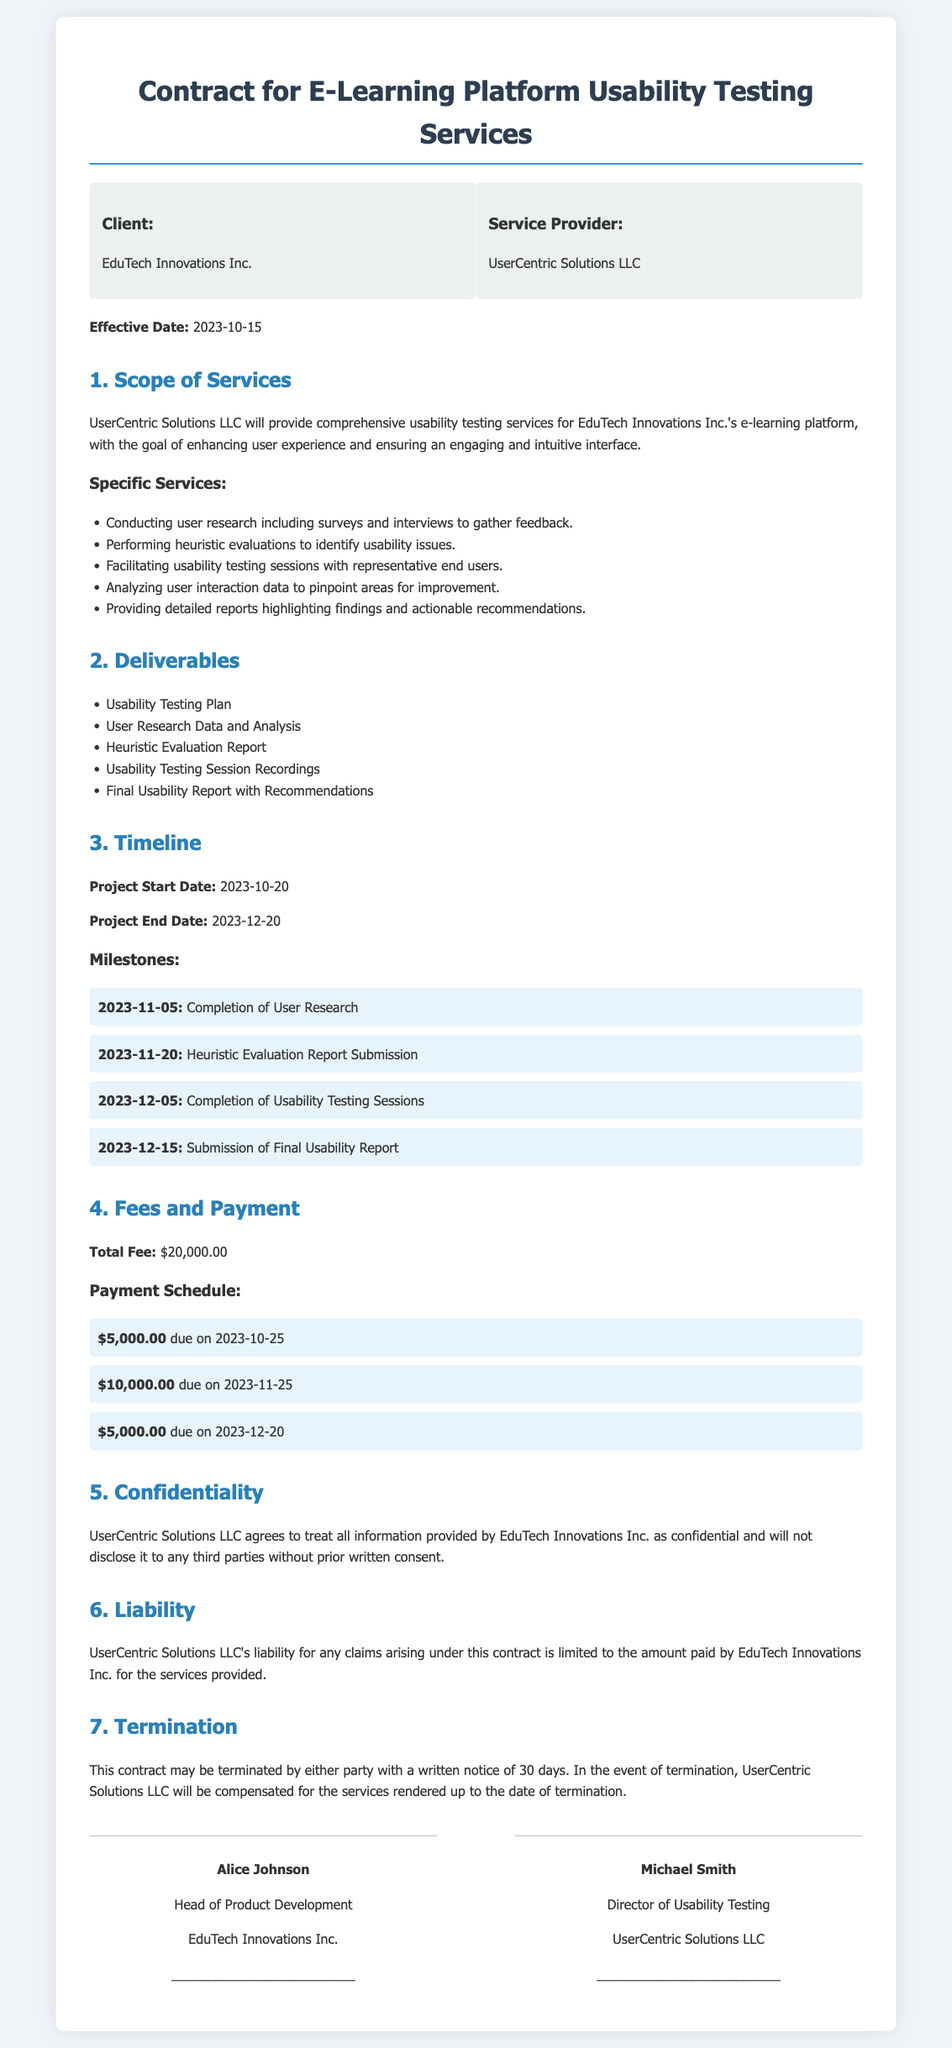What is the effective date of the contract? The effective date is explicitly stated in the document as the day when the contract takes effect.
Answer: 2023-10-15 Who is the service provider? The document specifies the name of the service provider responsible for usability testing services.
Answer: UserCentric Solutions LLC What is the total fee for the services provided? This information is found in the fees and payment section, detailing the complete amount to be paid.
Answer: $20,000.00 When is the completion of user research scheduled? The timeline section outlines the significant milestones of the project, including specific completion dates.
Answer: 2023-11-05 What documents will be included in the final deliverables? The deliverables section lists all items that the service provider will deliver to the client upon completion of the project.
Answer: Usability Testing Plan, User Research Data and Analysis, Heuristic Evaluation Report, Usability Testing Session Recordings, Final Usability Report with Recommendations What is the notice period for termination of the contract? The termination clause clearly mentions the time frame that either party must adhere to when intending to terminate the contract.
Answer: 30 days What is the liability limit for claims arising under this contract? The liability section indicates how much the service provider is accountable for in terms of the fees paid for the services.
Answer: Amount paid by EduTech Innovations Inc What is the project start date? The project start date is listed in the timeline section, marking when the services will commence.
Answer: 2023-10-20 What type of services will UserCentric Solutions LLC provide? The scope of services section outlines the range of usability testing services to be provided.
Answer: Comprehensive usability testing services 